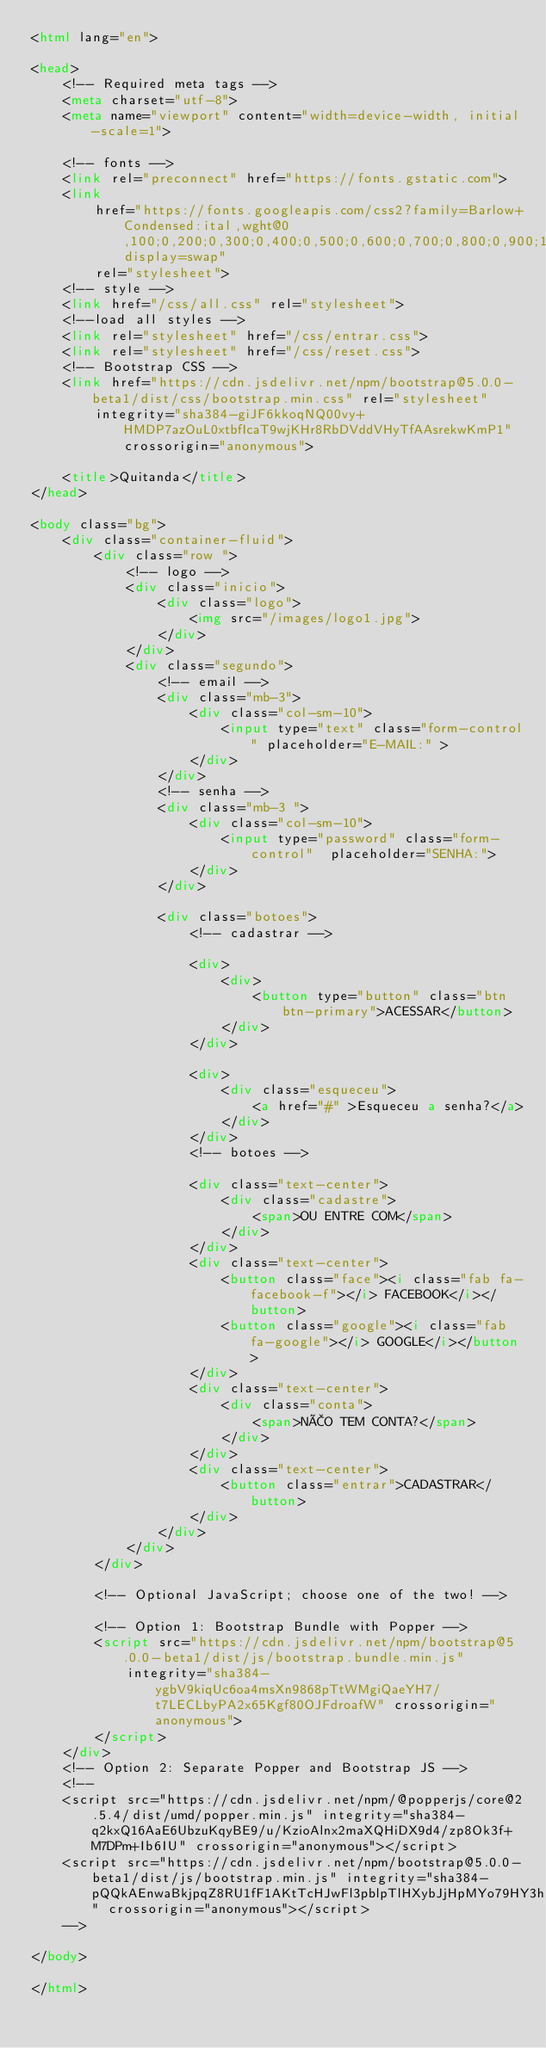Convert code to text. <code><loc_0><loc_0><loc_500><loc_500><_HTML_><html lang="en">

<head>
    <!-- Required meta tags -->
    <meta charset="utf-8">
    <meta name="viewport" content="width=device-width, initial-scale=1">

    <!-- fonts -->
    <link rel="preconnect" href="https://fonts.gstatic.com">
    <link
        href="https://fonts.googleapis.com/css2?family=Barlow+Condensed:ital,wght@0,100;0,200;0,300;0,400;0,500;0,600;0,700;0,800;0,900;1,100;1,200;1,300;1,400;1,500;1,600;1,700;1,800;1,900&display=swap"
        rel="stylesheet">
    <!-- style -->
    <link href="/css/all.css" rel="stylesheet">
    <!--load all styles -->
    <link rel="stylesheet" href="/css/entrar.css">
    <link rel="stylesheet" href="/css/reset.css">
    <!-- Bootstrap CSS -->
    <link href="https://cdn.jsdelivr.net/npm/bootstrap@5.0.0-beta1/dist/css/bootstrap.min.css" rel="stylesheet"
        integrity="sha384-giJF6kkoqNQ00vy+HMDP7azOuL0xtbfIcaT9wjKHr8RbDVddVHyTfAAsrekwKmP1" crossorigin="anonymous">

    <title>Quitanda</title>
</head>

<body class="bg">
    <div class="container-fluid">
        <div class="row ">
            <!-- logo -->
            <div class="inicio">
                <div class="logo">
                    <img src="/images/logo1.jpg">
                </div>
            </div>
            <div class="segundo">
                <!-- email -->
                <div class="mb-3">
                    <div class="col-sm-10">
                        <input type="text" class="form-control" placeholder="E-MAIL:" >
                    </div>
                </div>
                <!-- senha -->
                <div class="mb-3 ">
                    <div class="col-sm-10">
                        <input type="password" class="form-control"  placeholder="SENHA:">
                    </div>
                </div>

                <div class="botoes">
                    <!-- cadastrar -->

                    <div>
                        <div>
                            <button type="button" class="btn btn-primary">ACESSAR</button>
                        </div>
                    </div>

                    <div>
                        <div class="esqueceu">
                            <a href="#" >Esqueceu a senha?</a>
                        </div>
                    </div>
                    <!-- botoes -->

                    <div class="text-center">
                        <div class="cadastre">
                            <span>OU ENTRE COM</span>
                        </div>
                    </div>
                    <div class="text-center">
                        <button class="face"><i class="fab fa-facebook-f"></i> FACEBOOK</i></button>
                        <button class="google"><i class="fab fa-google"></i> GOOGLE</i></button>
                    </div>
                    <div class="text-center">
                        <div class="conta">
                            <span>NÃO TEM CONTA?</span>
                        </div>
                    </div>
                    <div class="text-center">
                        <button class="entrar">CADASTRAR</button>
                    </div>
                </div>
            </div>
        </div>

        <!-- Optional JavaScript; choose one of the two! -->

        <!-- Option 1: Bootstrap Bundle with Popper -->
        <script src="https://cdn.jsdelivr.net/npm/bootstrap@5.0.0-beta1/dist/js/bootstrap.bundle.min.js"
            integrity="sha384-ygbV9kiqUc6oa4msXn9868pTtWMgiQaeYH7/t7LECLbyPA2x65Kgf80OJFdroafW" crossorigin="anonymous">
        </script>
    </div>
    <!-- Option 2: Separate Popper and Bootstrap JS -->
    <!--
    <script src="https://cdn.jsdelivr.net/npm/@popperjs/core@2.5.4/dist/umd/popper.min.js" integrity="sha384-q2kxQ16AaE6UbzuKqyBE9/u/KzioAlnx2maXQHiDX9d4/zp8Ok3f+M7DPm+Ib6IU" crossorigin="anonymous"></script>
    <script src="https://cdn.jsdelivr.net/npm/bootstrap@5.0.0-beta1/dist/js/bootstrap.min.js" integrity="sha384-pQQkAEnwaBkjpqZ8RU1fF1AKtTcHJwFl3pblpTlHXybJjHpMYo79HY3hIi4NKxyj" crossorigin="anonymous"></script>
    -->

</body>

</html></code> 